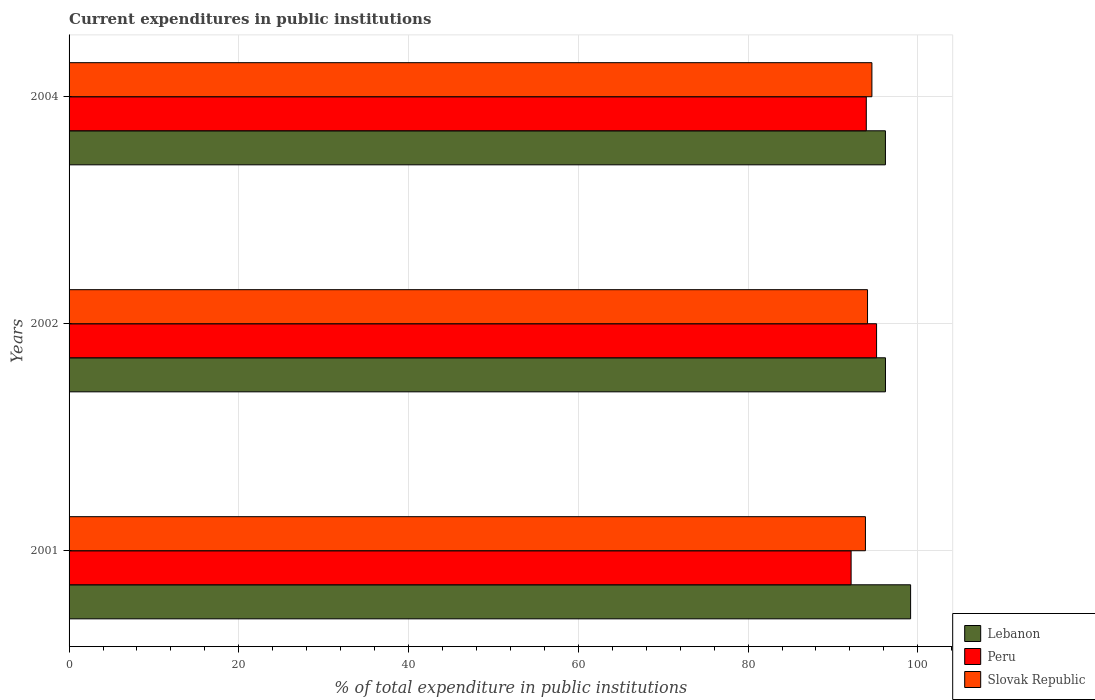How many different coloured bars are there?
Your answer should be very brief. 3. How many groups of bars are there?
Make the answer very short. 3. Are the number of bars per tick equal to the number of legend labels?
Offer a terse response. Yes. Are the number of bars on each tick of the Y-axis equal?
Keep it short and to the point. Yes. How many bars are there on the 3rd tick from the bottom?
Your answer should be compact. 3. What is the label of the 1st group of bars from the top?
Provide a succinct answer. 2004. What is the current expenditures in public institutions in Lebanon in 2001?
Make the answer very short. 99.15. Across all years, what is the maximum current expenditures in public institutions in Slovak Republic?
Ensure brevity in your answer.  94.59. Across all years, what is the minimum current expenditures in public institutions in Lebanon?
Make the answer very short. 96.18. In which year was the current expenditures in public institutions in Lebanon maximum?
Give a very brief answer. 2001. In which year was the current expenditures in public institutions in Peru minimum?
Keep it short and to the point. 2001. What is the total current expenditures in public institutions in Lebanon in the graph?
Make the answer very short. 291.52. What is the difference between the current expenditures in public institutions in Lebanon in 2002 and that in 2004?
Provide a short and direct response. 0.01. What is the difference between the current expenditures in public institutions in Peru in 2004 and the current expenditures in public institutions in Lebanon in 2002?
Provide a succinct answer. -2.26. What is the average current expenditures in public institutions in Slovak Republic per year?
Provide a succinct answer. 94.16. In the year 2001, what is the difference between the current expenditures in public institutions in Slovak Republic and current expenditures in public institutions in Lebanon?
Provide a succinct answer. -5.32. What is the ratio of the current expenditures in public institutions in Peru in 2001 to that in 2004?
Provide a succinct answer. 0.98. Is the current expenditures in public institutions in Peru in 2001 less than that in 2002?
Make the answer very short. Yes. What is the difference between the highest and the second highest current expenditures in public institutions in Lebanon?
Make the answer very short. 2.96. What is the difference between the highest and the lowest current expenditures in public institutions in Slovak Republic?
Provide a short and direct response. 0.76. Is the sum of the current expenditures in public institutions in Slovak Republic in 2001 and 2004 greater than the maximum current expenditures in public institutions in Lebanon across all years?
Offer a very short reply. Yes. What does the 2nd bar from the top in 2001 represents?
Keep it short and to the point. Peru. What does the 3rd bar from the bottom in 2002 represents?
Provide a short and direct response. Slovak Republic. Is it the case that in every year, the sum of the current expenditures in public institutions in Slovak Republic and current expenditures in public institutions in Lebanon is greater than the current expenditures in public institutions in Peru?
Provide a succinct answer. Yes. Are all the bars in the graph horizontal?
Keep it short and to the point. Yes. How many years are there in the graph?
Provide a succinct answer. 3. Does the graph contain grids?
Give a very brief answer. Yes. How are the legend labels stacked?
Your response must be concise. Vertical. What is the title of the graph?
Offer a very short reply. Current expenditures in public institutions. Does "Albania" appear as one of the legend labels in the graph?
Keep it short and to the point. No. What is the label or title of the X-axis?
Offer a very short reply. % of total expenditure in public institutions. What is the % of total expenditure in public institutions of Lebanon in 2001?
Your response must be concise. 99.15. What is the % of total expenditure in public institutions of Peru in 2001?
Give a very brief answer. 92.14. What is the % of total expenditure in public institutions of Slovak Republic in 2001?
Provide a short and direct response. 93.83. What is the % of total expenditure in public institutions in Lebanon in 2002?
Your answer should be very brief. 96.19. What is the % of total expenditure in public institutions in Peru in 2002?
Keep it short and to the point. 95.14. What is the % of total expenditure in public institutions in Slovak Republic in 2002?
Offer a terse response. 94.07. What is the % of total expenditure in public institutions of Lebanon in 2004?
Your response must be concise. 96.18. What is the % of total expenditure in public institutions in Peru in 2004?
Your answer should be very brief. 93.93. What is the % of total expenditure in public institutions of Slovak Republic in 2004?
Keep it short and to the point. 94.59. Across all years, what is the maximum % of total expenditure in public institutions in Lebanon?
Provide a short and direct response. 99.15. Across all years, what is the maximum % of total expenditure in public institutions in Peru?
Keep it short and to the point. 95.14. Across all years, what is the maximum % of total expenditure in public institutions in Slovak Republic?
Your answer should be compact. 94.59. Across all years, what is the minimum % of total expenditure in public institutions in Lebanon?
Provide a short and direct response. 96.18. Across all years, what is the minimum % of total expenditure in public institutions of Peru?
Offer a terse response. 92.14. Across all years, what is the minimum % of total expenditure in public institutions in Slovak Republic?
Make the answer very short. 93.83. What is the total % of total expenditure in public institutions in Lebanon in the graph?
Keep it short and to the point. 291.52. What is the total % of total expenditure in public institutions in Peru in the graph?
Keep it short and to the point. 281.2. What is the total % of total expenditure in public institutions in Slovak Republic in the graph?
Keep it short and to the point. 282.49. What is the difference between the % of total expenditure in public institutions in Lebanon in 2001 and that in 2002?
Your answer should be compact. 2.96. What is the difference between the % of total expenditure in public institutions of Peru in 2001 and that in 2002?
Offer a very short reply. -3. What is the difference between the % of total expenditure in public institutions of Slovak Republic in 2001 and that in 2002?
Make the answer very short. -0.25. What is the difference between the % of total expenditure in public institutions of Lebanon in 2001 and that in 2004?
Provide a short and direct response. 2.97. What is the difference between the % of total expenditure in public institutions of Peru in 2001 and that in 2004?
Your answer should be very brief. -1.79. What is the difference between the % of total expenditure in public institutions of Slovak Republic in 2001 and that in 2004?
Keep it short and to the point. -0.76. What is the difference between the % of total expenditure in public institutions in Lebanon in 2002 and that in 2004?
Provide a short and direct response. 0.01. What is the difference between the % of total expenditure in public institutions in Peru in 2002 and that in 2004?
Ensure brevity in your answer.  1.21. What is the difference between the % of total expenditure in public institutions of Slovak Republic in 2002 and that in 2004?
Offer a terse response. -0.52. What is the difference between the % of total expenditure in public institutions of Lebanon in 2001 and the % of total expenditure in public institutions of Peru in 2002?
Keep it short and to the point. 4.01. What is the difference between the % of total expenditure in public institutions in Lebanon in 2001 and the % of total expenditure in public institutions in Slovak Republic in 2002?
Provide a short and direct response. 5.07. What is the difference between the % of total expenditure in public institutions of Peru in 2001 and the % of total expenditure in public institutions of Slovak Republic in 2002?
Your answer should be very brief. -1.94. What is the difference between the % of total expenditure in public institutions of Lebanon in 2001 and the % of total expenditure in public institutions of Peru in 2004?
Provide a short and direct response. 5.22. What is the difference between the % of total expenditure in public institutions in Lebanon in 2001 and the % of total expenditure in public institutions in Slovak Republic in 2004?
Make the answer very short. 4.56. What is the difference between the % of total expenditure in public institutions in Peru in 2001 and the % of total expenditure in public institutions in Slovak Republic in 2004?
Your answer should be compact. -2.45. What is the difference between the % of total expenditure in public institutions in Lebanon in 2002 and the % of total expenditure in public institutions in Peru in 2004?
Keep it short and to the point. 2.26. What is the difference between the % of total expenditure in public institutions of Lebanon in 2002 and the % of total expenditure in public institutions of Slovak Republic in 2004?
Your answer should be compact. 1.6. What is the difference between the % of total expenditure in public institutions in Peru in 2002 and the % of total expenditure in public institutions in Slovak Republic in 2004?
Give a very brief answer. 0.55. What is the average % of total expenditure in public institutions of Lebanon per year?
Offer a terse response. 97.17. What is the average % of total expenditure in public institutions in Peru per year?
Your answer should be compact. 93.73. What is the average % of total expenditure in public institutions of Slovak Republic per year?
Keep it short and to the point. 94.16. In the year 2001, what is the difference between the % of total expenditure in public institutions of Lebanon and % of total expenditure in public institutions of Peru?
Provide a short and direct response. 7.01. In the year 2001, what is the difference between the % of total expenditure in public institutions in Lebanon and % of total expenditure in public institutions in Slovak Republic?
Offer a terse response. 5.32. In the year 2001, what is the difference between the % of total expenditure in public institutions in Peru and % of total expenditure in public institutions in Slovak Republic?
Your answer should be compact. -1.69. In the year 2002, what is the difference between the % of total expenditure in public institutions of Lebanon and % of total expenditure in public institutions of Peru?
Give a very brief answer. 1.05. In the year 2002, what is the difference between the % of total expenditure in public institutions in Lebanon and % of total expenditure in public institutions in Slovak Republic?
Offer a terse response. 2.11. In the year 2002, what is the difference between the % of total expenditure in public institutions of Peru and % of total expenditure in public institutions of Slovak Republic?
Offer a terse response. 1.06. In the year 2004, what is the difference between the % of total expenditure in public institutions of Lebanon and % of total expenditure in public institutions of Peru?
Make the answer very short. 2.25. In the year 2004, what is the difference between the % of total expenditure in public institutions of Lebanon and % of total expenditure in public institutions of Slovak Republic?
Offer a very short reply. 1.59. In the year 2004, what is the difference between the % of total expenditure in public institutions of Peru and % of total expenditure in public institutions of Slovak Republic?
Offer a terse response. -0.66. What is the ratio of the % of total expenditure in public institutions of Lebanon in 2001 to that in 2002?
Offer a very short reply. 1.03. What is the ratio of the % of total expenditure in public institutions of Peru in 2001 to that in 2002?
Provide a succinct answer. 0.97. What is the ratio of the % of total expenditure in public institutions of Lebanon in 2001 to that in 2004?
Your response must be concise. 1.03. What is the ratio of the % of total expenditure in public institutions of Peru in 2001 to that in 2004?
Make the answer very short. 0.98. What is the ratio of the % of total expenditure in public institutions in Lebanon in 2002 to that in 2004?
Ensure brevity in your answer.  1. What is the ratio of the % of total expenditure in public institutions of Peru in 2002 to that in 2004?
Keep it short and to the point. 1.01. What is the ratio of the % of total expenditure in public institutions in Slovak Republic in 2002 to that in 2004?
Give a very brief answer. 0.99. What is the difference between the highest and the second highest % of total expenditure in public institutions of Lebanon?
Offer a very short reply. 2.96. What is the difference between the highest and the second highest % of total expenditure in public institutions of Peru?
Your answer should be compact. 1.21. What is the difference between the highest and the second highest % of total expenditure in public institutions in Slovak Republic?
Provide a short and direct response. 0.52. What is the difference between the highest and the lowest % of total expenditure in public institutions of Lebanon?
Provide a short and direct response. 2.97. What is the difference between the highest and the lowest % of total expenditure in public institutions of Peru?
Give a very brief answer. 3. What is the difference between the highest and the lowest % of total expenditure in public institutions in Slovak Republic?
Your response must be concise. 0.76. 